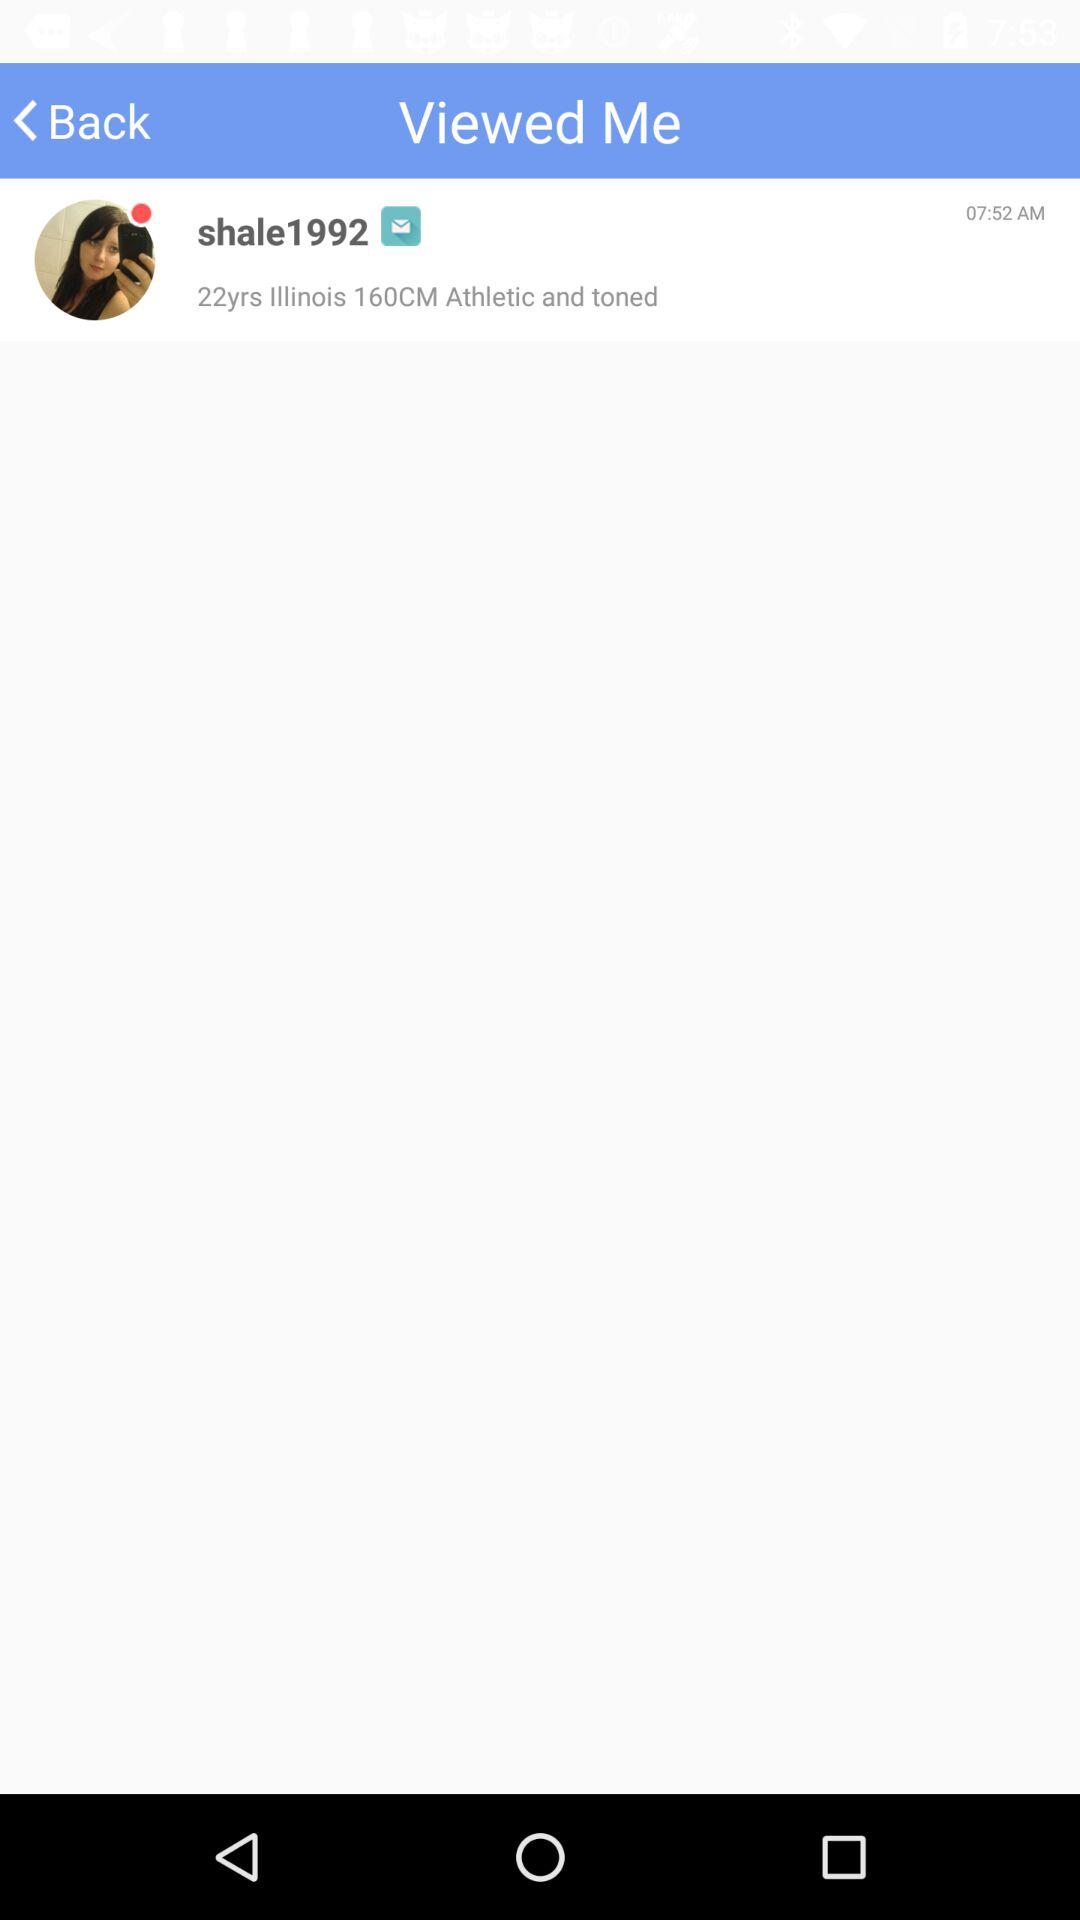What is the time? The time is 07:52 AM. 